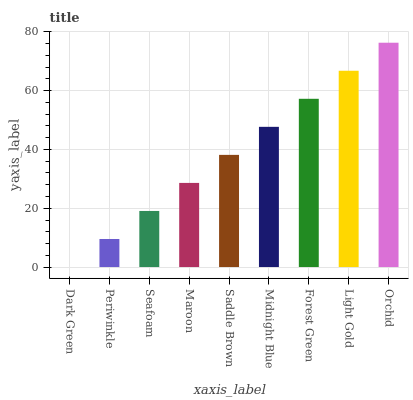Is Dark Green the minimum?
Answer yes or no. Yes. Is Orchid the maximum?
Answer yes or no. Yes. Is Periwinkle the minimum?
Answer yes or no. No. Is Periwinkle the maximum?
Answer yes or no. No. Is Periwinkle greater than Dark Green?
Answer yes or no. Yes. Is Dark Green less than Periwinkle?
Answer yes or no. Yes. Is Dark Green greater than Periwinkle?
Answer yes or no. No. Is Periwinkle less than Dark Green?
Answer yes or no. No. Is Saddle Brown the high median?
Answer yes or no. Yes. Is Saddle Brown the low median?
Answer yes or no. Yes. Is Light Gold the high median?
Answer yes or no. No. Is Seafoam the low median?
Answer yes or no. No. 